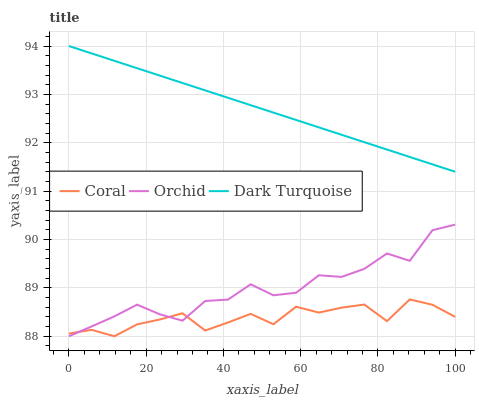Does Coral have the minimum area under the curve?
Answer yes or no. Yes. Does Dark Turquoise have the maximum area under the curve?
Answer yes or no. Yes. Does Orchid have the minimum area under the curve?
Answer yes or no. No. Does Orchid have the maximum area under the curve?
Answer yes or no. No. Is Dark Turquoise the smoothest?
Answer yes or no. Yes. Is Orchid the roughest?
Answer yes or no. Yes. Is Coral the smoothest?
Answer yes or no. No. Is Coral the roughest?
Answer yes or no. No. Does Coral have the lowest value?
Answer yes or no. Yes. Does Dark Turquoise have the highest value?
Answer yes or no. Yes. Does Orchid have the highest value?
Answer yes or no. No. Is Coral less than Dark Turquoise?
Answer yes or no. Yes. Is Dark Turquoise greater than Coral?
Answer yes or no. Yes. Does Coral intersect Orchid?
Answer yes or no. Yes. Is Coral less than Orchid?
Answer yes or no. No. Is Coral greater than Orchid?
Answer yes or no. No. Does Coral intersect Dark Turquoise?
Answer yes or no. No. 